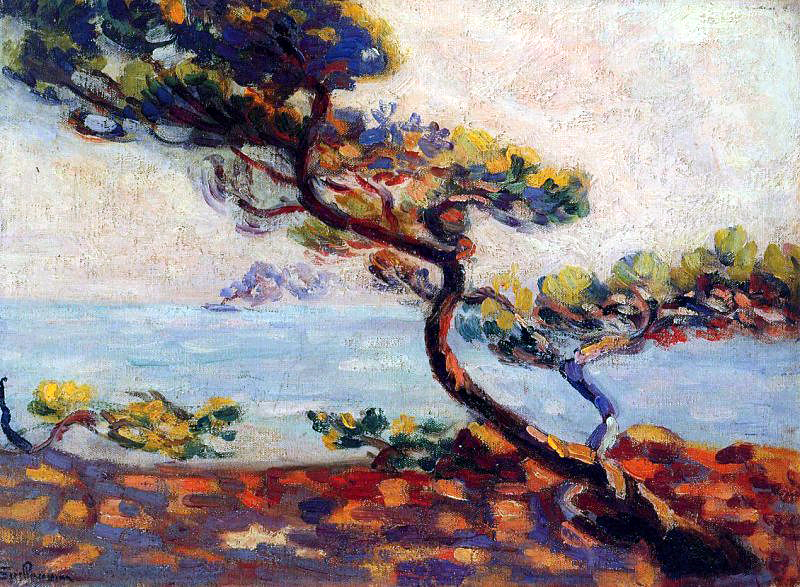Can you elaborate on the elements of the picture provided? This striking impressionist painting vividly portrays a solitary tree on a rocky shore. The tree, with its twisted and gnarled form, stands out as a prominent feature. Its leaves exhibit a vibrant mix of green, blue, and yellow, providing a dynamic splash of color against the landscape.

In the background, the serene seascape captivates with its clear blue waters meeting a sky filled with fluffy white clouds. The colors are bright and lively, imbuing the scene with energy and life.

The painting's style is reminiscent of Claude Monet, renowned for his impressionist works. The loose, fluid brushstrokes characteristic of this style lend the painting a sense of movement and spontaneity.

The landscape depicted likely hails from the French Riviera, a region celebrated for its breathtaking natural beauty. The rocky shore and solitary tree are common elements of this region's scenery.

Overall, this artwork beautifully encapsulates the essence of impressionist art through its vibrant colors and dynamic brushstrokes, masterfully capturing the natural world's vitality and beauty. 